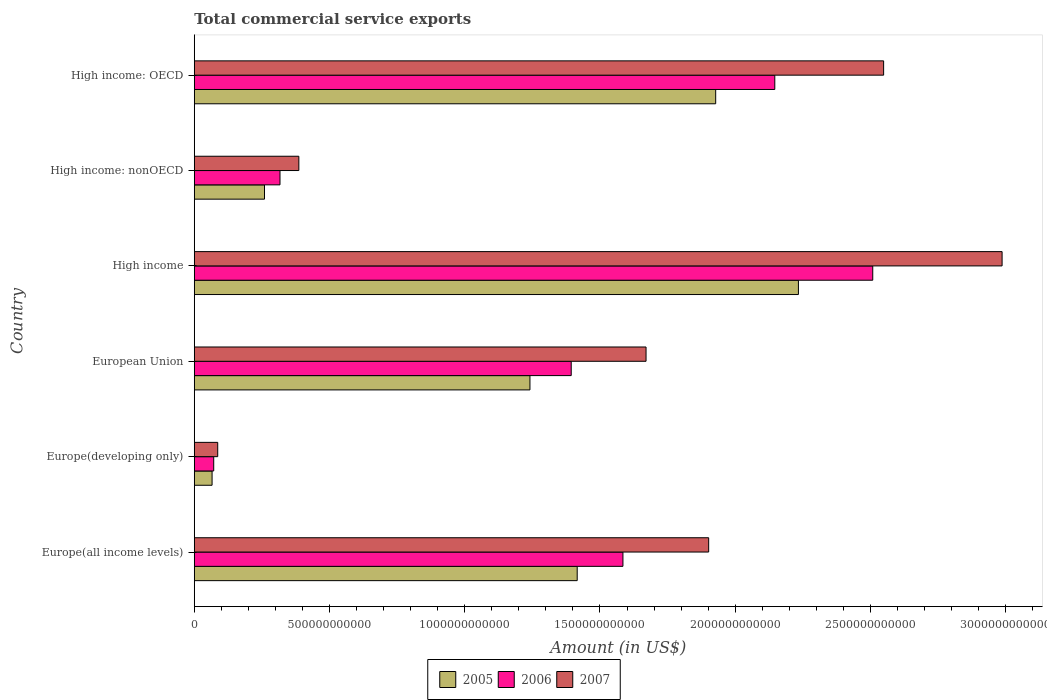How many groups of bars are there?
Provide a succinct answer. 6. Are the number of bars per tick equal to the number of legend labels?
Provide a short and direct response. Yes. Are the number of bars on each tick of the Y-axis equal?
Ensure brevity in your answer.  Yes. How many bars are there on the 3rd tick from the top?
Provide a succinct answer. 3. How many bars are there on the 6th tick from the bottom?
Provide a succinct answer. 3. What is the label of the 4th group of bars from the top?
Keep it short and to the point. European Union. What is the total commercial service exports in 2006 in High income: nonOECD?
Provide a short and direct response. 3.17e+11. Across all countries, what is the maximum total commercial service exports in 2005?
Ensure brevity in your answer.  2.23e+12. Across all countries, what is the minimum total commercial service exports in 2006?
Offer a terse response. 7.19e+1. In which country was the total commercial service exports in 2006 maximum?
Ensure brevity in your answer.  High income. In which country was the total commercial service exports in 2005 minimum?
Provide a short and direct response. Europe(developing only). What is the total total commercial service exports in 2006 in the graph?
Your answer should be compact. 8.02e+12. What is the difference between the total commercial service exports in 2005 in Europe(developing only) and that in High income: nonOECD?
Your answer should be compact. -1.94e+11. What is the difference between the total commercial service exports in 2005 in Europe(developing only) and the total commercial service exports in 2007 in Europe(all income levels)?
Offer a terse response. -1.84e+12. What is the average total commercial service exports in 2006 per country?
Keep it short and to the point. 1.34e+12. What is the difference between the total commercial service exports in 2006 and total commercial service exports in 2007 in High income?
Your answer should be very brief. -4.78e+11. What is the ratio of the total commercial service exports in 2005 in Europe(developing only) to that in High income: OECD?
Give a very brief answer. 0.03. Is the difference between the total commercial service exports in 2006 in Europe(all income levels) and High income: nonOECD greater than the difference between the total commercial service exports in 2007 in Europe(all income levels) and High income: nonOECD?
Provide a succinct answer. No. What is the difference between the highest and the second highest total commercial service exports in 2007?
Provide a short and direct response. 4.38e+11. What is the difference between the highest and the lowest total commercial service exports in 2006?
Your answer should be compact. 2.44e+12. Is the sum of the total commercial service exports in 2005 in Europe(developing only) and High income: nonOECD greater than the maximum total commercial service exports in 2007 across all countries?
Provide a succinct answer. No. What does the 2nd bar from the top in High income: OECD represents?
Provide a short and direct response. 2006. How many bars are there?
Give a very brief answer. 18. How many countries are there in the graph?
Keep it short and to the point. 6. What is the difference between two consecutive major ticks on the X-axis?
Provide a short and direct response. 5.00e+11. Are the values on the major ticks of X-axis written in scientific E-notation?
Make the answer very short. No. Does the graph contain any zero values?
Provide a succinct answer. No. What is the title of the graph?
Make the answer very short. Total commercial service exports. What is the label or title of the Y-axis?
Your answer should be very brief. Country. What is the Amount (in US$) of 2005 in Europe(all income levels)?
Offer a terse response. 1.42e+12. What is the Amount (in US$) in 2006 in Europe(all income levels)?
Give a very brief answer. 1.58e+12. What is the Amount (in US$) of 2007 in Europe(all income levels)?
Keep it short and to the point. 1.90e+12. What is the Amount (in US$) in 2005 in Europe(developing only)?
Keep it short and to the point. 6.59e+1. What is the Amount (in US$) in 2006 in Europe(developing only)?
Provide a succinct answer. 7.19e+1. What is the Amount (in US$) in 2007 in Europe(developing only)?
Offer a terse response. 8.67e+1. What is the Amount (in US$) of 2005 in European Union?
Ensure brevity in your answer.  1.24e+12. What is the Amount (in US$) in 2006 in European Union?
Offer a very short reply. 1.39e+12. What is the Amount (in US$) of 2007 in European Union?
Give a very brief answer. 1.67e+12. What is the Amount (in US$) of 2005 in High income?
Your response must be concise. 2.23e+12. What is the Amount (in US$) of 2006 in High income?
Provide a short and direct response. 2.51e+12. What is the Amount (in US$) of 2007 in High income?
Your answer should be compact. 2.99e+12. What is the Amount (in US$) of 2005 in High income: nonOECD?
Provide a short and direct response. 2.60e+11. What is the Amount (in US$) in 2006 in High income: nonOECD?
Keep it short and to the point. 3.17e+11. What is the Amount (in US$) of 2007 in High income: nonOECD?
Your answer should be compact. 3.87e+11. What is the Amount (in US$) in 2005 in High income: OECD?
Provide a short and direct response. 1.93e+12. What is the Amount (in US$) in 2006 in High income: OECD?
Offer a terse response. 2.15e+12. What is the Amount (in US$) in 2007 in High income: OECD?
Your answer should be compact. 2.55e+12. Across all countries, what is the maximum Amount (in US$) in 2005?
Make the answer very short. 2.23e+12. Across all countries, what is the maximum Amount (in US$) in 2006?
Offer a very short reply. 2.51e+12. Across all countries, what is the maximum Amount (in US$) in 2007?
Your response must be concise. 2.99e+12. Across all countries, what is the minimum Amount (in US$) in 2005?
Make the answer very short. 6.59e+1. Across all countries, what is the minimum Amount (in US$) in 2006?
Make the answer very short. 7.19e+1. Across all countries, what is the minimum Amount (in US$) in 2007?
Give a very brief answer. 8.67e+1. What is the total Amount (in US$) of 2005 in the graph?
Offer a very short reply. 7.14e+12. What is the total Amount (in US$) of 2006 in the graph?
Give a very brief answer. 8.02e+12. What is the total Amount (in US$) in 2007 in the graph?
Ensure brevity in your answer.  9.58e+12. What is the difference between the Amount (in US$) of 2005 in Europe(all income levels) and that in Europe(developing only)?
Make the answer very short. 1.35e+12. What is the difference between the Amount (in US$) in 2006 in Europe(all income levels) and that in Europe(developing only)?
Your response must be concise. 1.51e+12. What is the difference between the Amount (in US$) in 2007 in Europe(all income levels) and that in Europe(developing only)?
Provide a short and direct response. 1.82e+12. What is the difference between the Amount (in US$) in 2005 in Europe(all income levels) and that in European Union?
Offer a very short reply. 1.75e+11. What is the difference between the Amount (in US$) of 2006 in Europe(all income levels) and that in European Union?
Your answer should be very brief. 1.91e+11. What is the difference between the Amount (in US$) of 2007 in Europe(all income levels) and that in European Union?
Your answer should be very brief. 2.32e+11. What is the difference between the Amount (in US$) in 2005 in Europe(all income levels) and that in High income?
Provide a succinct answer. -8.18e+11. What is the difference between the Amount (in US$) of 2006 in Europe(all income levels) and that in High income?
Provide a succinct answer. -9.24e+11. What is the difference between the Amount (in US$) of 2007 in Europe(all income levels) and that in High income?
Provide a succinct answer. -1.08e+12. What is the difference between the Amount (in US$) of 2005 in Europe(all income levels) and that in High income: nonOECD?
Offer a terse response. 1.16e+12. What is the difference between the Amount (in US$) in 2006 in Europe(all income levels) and that in High income: nonOECD?
Keep it short and to the point. 1.27e+12. What is the difference between the Amount (in US$) of 2007 in Europe(all income levels) and that in High income: nonOECD?
Make the answer very short. 1.52e+12. What is the difference between the Amount (in US$) of 2005 in Europe(all income levels) and that in High income: OECD?
Make the answer very short. -5.12e+11. What is the difference between the Amount (in US$) of 2006 in Europe(all income levels) and that in High income: OECD?
Your answer should be very brief. -5.61e+11. What is the difference between the Amount (in US$) of 2007 in Europe(all income levels) and that in High income: OECD?
Ensure brevity in your answer.  -6.47e+11. What is the difference between the Amount (in US$) in 2005 in Europe(developing only) and that in European Union?
Offer a very short reply. -1.18e+12. What is the difference between the Amount (in US$) of 2006 in Europe(developing only) and that in European Union?
Make the answer very short. -1.32e+12. What is the difference between the Amount (in US$) of 2007 in Europe(developing only) and that in European Union?
Your answer should be very brief. -1.58e+12. What is the difference between the Amount (in US$) of 2005 in Europe(developing only) and that in High income?
Your answer should be very brief. -2.17e+12. What is the difference between the Amount (in US$) in 2006 in Europe(developing only) and that in High income?
Provide a short and direct response. -2.44e+12. What is the difference between the Amount (in US$) of 2007 in Europe(developing only) and that in High income?
Make the answer very short. -2.90e+12. What is the difference between the Amount (in US$) in 2005 in Europe(developing only) and that in High income: nonOECD?
Ensure brevity in your answer.  -1.94e+11. What is the difference between the Amount (in US$) of 2006 in Europe(developing only) and that in High income: nonOECD?
Make the answer very short. -2.45e+11. What is the difference between the Amount (in US$) of 2007 in Europe(developing only) and that in High income: nonOECD?
Your response must be concise. -3.00e+11. What is the difference between the Amount (in US$) of 2005 in Europe(developing only) and that in High income: OECD?
Make the answer very short. -1.86e+12. What is the difference between the Amount (in US$) in 2006 in Europe(developing only) and that in High income: OECD?
Offer a terse response. -2.07e+12. What is the difference between the Amount (in US$) of 2007 in Europe(developing only) and that in High income: OECD?
Ensure brevity in your answer.  -2.46e+12. What is the difference between the Amount (in US$) of 2005 in European Union and that in High income?
Keep it short and to the point. -9.93e+11. What is the difference between the Amount (in US$) of 2006 in European Union and that in High income?
Provide a succinct answer. -1.11e+12. What is the difference between the Amount (in US$) in 2007 in European Union and that in High income?
Provide a succinct answer. -1.32e+12. What is the difference between the Amount (in US$) of 2005 in European Union and that in High income: nonOECD?
Your answer should be compact. 9.81e+11. What is the difference between the Amount (in US$) in 2006 in European Union and that in High income: nonOECD?
Your answer should be compact. 1.08e+12. What is the difference between the Amount (in US$) of 2007 in European Union and that in High income: nonOECD?
Keep it short and to the point. 1.28e+12. What is the difference between the Amount (in US$) of 2005 in European Union and that in High income: OECD?
Give a very brief answer. -6.87e+11. What is the difference between the Amount (in US$) of 2006 in European Union and that in High income: OECD?
Your answer should be very brief. -7.53e+11. What is the difference between the Amount (in US$) in 2007 in European Union and that in High income: OECD?
Keep it short and to the point. -8.78e+11. What is the difference between the Amount (in US$) of 2005 in High income and that in High income: nonOECD?
Provide a short and direct response. 1.97e+12. What is the difference between the Amount (in US$) in 2006 in High income and that in High income: nonOECD?
Your answer should be very brief. 2.19e+12. What is the difference between the Amount (in US$) of 2007 in High income and that in High income: nonOECD?
Your answer should be very brief. 2.60e+12. What is the difference between the Amount (in US$) in 2005 in High income and that in High income: OECD?
Make the answer very short. 3.06e+11. What is the difference between the Amount (in US$) in 2006 in High income and that in High income: OECD?
Your answer should be compact. 3.62e+11. What is the difference between the Amount (in US$) in 2007 in High income and that in High income: OECD?
Offer a very short reply. 4.38e+11. What is the difference between the Amount (in US$) in 2005 in High income: nonOECD and that in High income: OECD?
Your answer should be compact. -1.67e+12. What is the difference between the Amount (in US$) in 2006 in High income: nonOECD and that in High income: OECD?
Give a very brief answer. -1.83e+12. What is the difference between the Amount (in US$) in 2007 in High income: nonOECD and that in High income: OECD?
Provide a succinct answer. -2.16e+12. What is the difference between the Amount (in US$) in 2005 in Europe(all income levels) and the Amount (in US$) in 2006 in Europe(developing only)?
Your response must be concise. 1.34e+12. What is the difference between the Amount (in US$) in 2005 in Europe(all income levels) and the Amount (in US$) in 2007 in Europe(developing only)?
Your answer should be very brief. 1.33e+12. What is the difference between the Amount (in US$) of 2006 in Europe(all income levels) and the Amount (in US$) of 2007 in Europe(developing only)?
Offer a very short reply. 1.50e+12. What is the difference between the Amount (in US$) of 2005 in Europe(all income levels) and the Amount (in US$) of 2006 in European Union?
Keep it short and to the point. 2.21e+1. What is the difference between the Amount (in US$) of 2005 in Europe(all income levels) and the Amount (in US$) of 2007 in European Union?
Offer a very short reply. -2.55e+11. What is the difference between the Amount (in US$) of 2006 in Europe(all income levels) and the Amount (in US$) of 2007 in European Union?
Your answer should be compact. -8.55e+1. What is the difference between the Amount (in US$) of 2005 in Europe(all income levels) and the Amount (in US$) of 2006 in High income?
Your response must be concise. -1.09e+12. What is the difference between the Amount (in US$) of 2005 in Europe(all income levels) and the Amount (in US$) of 2007 in High income?
Provide a short and direct response. -1.57e+12. What is the difference between the Amount (in US$) of 2006 in Europe(all income levels) and the Amount (in US$) of 2007 in High income?
Your answer should be very brief. -1.40e+12. What is the difference between the Amount (in US$) of 2005 in Europe(all income levels) and the Amount (in US$) of 2006 in High income: nonOECD?
Offer a very short reply. 1.10e+12. What is the difference between the Amount (in US$) of 2005 in Europe(all income levels) and the Amount (in US$) of 2007 in High income: nonOECD?
Make the answer very short. 1.03e+12. What is the difference between the Amount (in US$) in 2006 in Europe(all income levels) and the Amount (in US$) in 2007 in High income: nonOECD?
Your response must be concise. 1.20e+12. What is the difference between the Amount (in US$) of 2005 in Europe(all income levels) and the Amount (in US$) of 2006 in High income: OECD?
Give a very brief answer. -7.31e+11. What is the difference between the Amount (in US$) of 2005 in Europe(all income levels) and the Amount (in US$) of 2007 in High income: OECD?
Offer a terse response. -1.13e+12. What is the difference between the Amount (in US$) of 2006 in Europe(all income levels) and the Amount (in US$) of 2007 in High income: OECD?
Keep it short and to the point. -9.64e+11. What is the difference between the Amount (in US$) in 2005 in Europe(developing only) and the Amount (in US$) in 2006 in European Union?
Your response must be concise. -1.33e+12. What is the difference between the Amount (in US$) of 2005 in Europe(developing only) and the Amount (in US$) of 2007 in European Union?
Ensure brevity in your answer.  -1.60e+12. What is the difference between the Amount (in US$) of 2006 in Europe(developing only) and the Amount (in US$) of 2007 in European Union?
Make the answer very short. -1.60e+12. What is the difference between the Amount (in US$) of 2005 in Europe(developing only) and the Amount (in US$) of 2006 in High income?
Your answer should be compact. -2.44e+12. What is the difference between the Amount (in US$) of 2005 in Europe(developing only) and the Amount (in US$) of 2007 in High income?
Provide a short and direct response. -2.92e+12. What is the difference between the Amount (in US$) in 2006 in Europe(developing only) and the Amount (in US$) in 2007 in High income?
Your answer should be very brief. -2.91e+12. What is the difference between the Amount (in US$) of 2005 in Europe(developing only) and the Amount (in US$) of 2006 in High income: nonOECD?
Offer a terse response. -2.51e+11. What is the difference between the Amount (in US$) of 2005 in Europe(developing only) and the Amount (in US$) of 2007 in High income: nonOECD?
Your answer should be compact. -3.21e+11. What is the difference between the Amount (in US$) in 2006 in Europe(developing only) and the Amount (in US$) in 2007 in High income: nonOECD?
Your answer should be very brief. -3.15e+11. What is the difference between the Amount (in US$) in 2005 in Europe(developing only) and the Amount (in US$) in 2006 in High income: OECD?
Make the answer very short. -2.08e+12. What is the difference between the Amount (in US$) of 2005 in Europe(developing only) and the Amount (in US$) of 2007 in High income: OECD?
Give a very brief answer. -2.48e+12. What is the difference between the Amount (in US$) in 2006 in Europe(developing only) and the Amount (in US$) in 2007 in High income: OECD?
Offer a very short reply. -2.48e+12. What is the difference between the Amount (in US$) of 2005 in European Union and the Amount (in US$) of 2006 in High income?
Offer a terse response. -1.27e+12. What is the difference between the Amount (in US$) of 2005 in European Union and the Amount (in US$) of 2007 in High income?
Provide a short and direct response. -1.75e+12. What is the difference between the Amount (in US$) of 2006 in European Union and the Amount (in US$) of 2007 in High income?
Keep it short and to the point. -1.59e+12. What is the difference between the Amount (in US$) of 2005 in European Union and the Amount (in US$) of 2006 in High income: nonOECD?
Keep it short and to the point. 9.24e+11. What is the difference between the Amount (in US$) in 2005 in European Union and the Amount (in US$) in 2007 in High income: nonOECD?
Give a very brief answer. 8.55e+11. What is the difference between the Amount (in US$) in 2006 in European Union and the Amount (in US$) in 2007 in High income: nonOECD?
Keep it short and to the point. 1.01e+12. What is the difference between the Amount (in US$) of 2005 in European Union and the Amount (in US$) of 2006 in High income: OECD?
Make the answer very short. -9.05e+11. What is the difference between the Amount (in US$) of 2005 in European Union and the Amount (in US$) of 2007 in High income: OECD?
Your answer should be compact. -1.31e+12. What is the difference between the Amount (in US$) of 2006 in European Union and the Amount (in US$) of 2007 in High income: OECD?
Your answer should be very brief. -1.16e+12. What is the difference between the Amount (in US$) in 2005 in High income and the Amount (in US$) in 2006 in High income: nonOECD?
Offer a very short reply. 1.92e+12. What is the difference between the Amount (in US$) of 2005 in High income and the Amount (in US$) of 2007 in High income: nonOECD?
Offer a terse response. 1.85e+12. What is the difference between the Amount (in US$) of 2006 in High income and the Amount (in US$) of 2007 in High income: nonOECD?
Keep it short and to the point. 2.12e+12. What is the difference between the Amount (in US$) in 2005 in High income and the Amount (in US$) in 2006 in High income: OECD?
Give a very brief answer. 8.74e+1. What is the difference between the Amount (in US$) of 2005 in High income and the Amount (in US$) of 2007 in High income: OECD?
Give a very brief answer. -3.15e+11. What is the difference between the Amount (in US$) of 2006 in High income and the Amount (in US$) of 2007 in High income: OECD?
Give a very brief answer. -4.02e+1. What is the difference between the Amount (in US$) of 2005 in High income: nonOECD and the Amount (in US$) of 2006 in High income: OECD?
Provide a short and direct response. -1.89e+12. What is the difference between the Amount (in US$) in 2005 in High income: nonOECD and the Amount (in US$) in 2007 in High income: OECD?
Give a very brief answer. -2.29e+12. What is the difference between the Amount (in US$) in 2006 in High income: nonOECD and the Amount (in US$) in 2007 in High income: OECD?
Keep it short and to the point. -2.23e+12. What is the average Amount (in US$) in 2005 per country?
Provide a succinct answer. 1.19e+12. What is the average Amount (in US$) in 2006 per country?
Ensure brevity in your answer.  1.34e+12. What is the average Amount (in US$) in 2007 per country?
Your answer should be very brief. 1.60e+12. What is the difference between the Amount (in US$) of 2005 and Amount (in US$) of 2006 in Europe(all income levels)?
Ensure brevity in your answer.  -1.69e+11. What is the difference between the Amount (in US$) in 2005 and Amount (in US$) in 2007 in Europe(all income levels)?
Your answer should be very brief. -4.86e+11. What is the difference between the Amount (in US$) in 2006 and Amount (in US$) in 2007 in Europe(all income levels)?
Provide a short and direct response. -3.17e+11. What is the difference between the Amount (in US$) of 2005 and Amount (in US$) of 2006 in Europe(developing only)?
Ensure brevity in your answer.  -6.08e+09. What is the difference between the Amount (in US$) of 2005 and Amount (in US$) of 2007 in Europe(developing only)?
Provide a succinct answer. -2.09e+1. What is the difference between the Amount (in US$) in 2006 and Amount (in US$) in 2007 in Europe(developing only)?
Provide a succinct answer. -1.48e+1. What is the difference between the Amount (in US$) in 2005 and Amount (in US$) in 2006 in European Union?
Offer a very short reply. -1.53e+11. What is the difference between the Amount (in US$) of 2005 and Amount (in US$) of 2007 in European Union?
Your answer should be compact. -4.29e+11. What is the difference between the Amount (in US$) in 2006 and Amount (in US$) in 2007 in European Union?
Make the answer very short. -2.77e+11. What is the difference between the Amount (in US$) of 2005 and Amount (in US$) of 2006 in High income?
Keep it short and to the point. -2.75e+11. What is the difference between the Amount (in US$) in 2005 and Amount (in US$) in 2007 in High income?
Keep it short and to the point. -7.53e+11. What is the difference between the Amount (in US$) of 2006 and Amount (in US$) of 2007 in High income?
Your response must be concise. -4.78e+11. What is the difference between the Amount (in US$) of 2005 and Amount (in US$) of 2006 in High income: nonOECD?
Offer a terse response. -5.73e+1. What is the difference between the Amount (in US$) of 2005 and Amount (in US$) of 2007 in High income: nonOECD?
Ensure brevity in your answer.  -1.27e+11. What is the difference between the Amount (in US$) of 2006 and Amount (in US$) of 2007 in High income: nonOECD?
Offer a very short reply. -6.97e+1. What is the difference between the Amount (in US$) in 2005 and Amount (in US$) in 2006 in High income: OECD?
Your response must be concise. -2.19e+11. What is the difference between the Amount (in US$) of 2005 and Amount (in US$) of 2007 in High income: OECD?
Make the answer very short. -6.21e+11. What is the difference between the Amount (in US$) of 2006 and Amount (in US$) of 2007 in High income: OECD?
Offer a very short reply. -4.02e+11. What is the ratio of the Amount (in US$) in 2005 in Europe(all income levels) to that in Europe(developing only)?
Offer a very short reply. 21.5. What is the ratio of the Amount (in US$) in 2006 in Europe(all income levels) to that in Europe(developing only)?
Provide a short and direct response. 22.03. What is the ratio of the Amount (in US$) in 2007 in Europe(all income levels) to that in Europe(developing only)?
Make the answer very short. 21.93. What is the ratio of the Amount (in US$) of 2005 in Europe(all income levels) to that in European Union?
Offer a very short reply. 1.14. What is the ratio of the Amount (in US$) in 2006 in Europe(all income levels) to that in European Union?
Your answer should be compact. 1.14. What is the ratio of the Amount (in US$) of 2007 in Europe(all income levels) to that in European Union?
Ensure brevity in your answer.  1.14. What is the ratio of the Amount (in US$) of 2005 in Europe(all income levels) to that in High income?
Offer a terse response. 0.63. What is the ratio of the Amount (in US$) of 2006 in Europe(all income levels) to that in High income?
Make the answer very short. 0.63. What is the ratio of the Amount (in US$) of 2007 in Europe(all income levels) to that in High income?
Keep it short and to the point. 0.64. What is the ratio of the Amount (in US$) of 2005 in Europe(all income levels) to that in High income: nonOECD?
Offer a very short reply. 5.45. What is the ratio of the Amount (in US$) in 2006 in Europe(all income levels) to that in High income: nonOECD?
Keep it short and to the point. 5. What is the ratio of the Amount (in US$) in 2007 in Europe(all income levels) to that in High income: nonOECD?
Make the answer very short. 4.92. What is the ratio of the Amount (in US$) in 2005 in Europe(all income levels) to that in High income: OECD?
Your answer should be very brief. 0.73. What is the ratio of the Amount (in US$) in 2006 in Europe(all income levels) to that in High income: OECD?
Offer a terse response. 0.74. What is the ratio of the Amount (in US$) in 2007 in Europe(all income levels) to that in High income: OECD?
Provide a succinct answer. 0.75. What is the ratio of the Amount (in US$) of 2005 in Europe(developing only) to that in European Union?
Keep it short and to the point. 0.05. What is the ratio of the Amount (in US$) of 2006 in Europe(developing only) to that in European Union?
Give a very brief answer. 0.05. What is the ratio of the Amount (in US$) of 2007 in Europe(developing only) to that in European Union?
Your answer should be very brief. 0.05. What is the ratio of the Amount (in US$) in 2005 in Europe(developing only) to that in High income?
Your response must be concise. 0.03. What is the ratio of the Amount (in US$) in 2006 in Europe(developing only) to that in High income?
Give a very brief answer. 0.03. What is the ratio of the Amount (in US$) in 2007 in Europe(developing only) to that in High income?
Offer a very short reply. 0.03. What is the ratio of the Amount (in US$) in 2005 in Europe(developing only) to that in High income: nonOECD?
Your response must be concise. 0.25. What is the ratio of the Amount (in US$) of 2006 in Europe(developing only) to that in High income: nonOECD?
Offer a very short reply. 0.23. What is the ratio of the Amount (in US$) of 2007 in Europe(developing only) to that in High income: nonOECD?
Provide a succinct answer. 0.22. What is the ratio of the Amount (in US$) in 2005 in Europe(developing only) to that in High income: OECD?
Your answer should be compact. 0.03. What is the ratio of the Amount (in US$) of 2006 in Europe(developing only) to that in High income: OECD?
Your response must be concise. 0.03. What is the ratio of the Amount (in US$) of 2007 in Europe(developing only) to that in High income: OECD?
Give a very brief answer. 0.03. What is the ratio of the Amount (in US$) of 2005 in European Union to that in High income?
Ensure brevity in your answer.  0.56. What is the ratio of the Amount (in US$) in 2006 in European Union to that in High income?
Ensure brevity in your answer.  0.56. What is the ratio of the Amount (in US$) of 2007 in European Union to that in High income?
Offer a terse response. 0.56. What is the ratio of the Amount (in US$) of 2005 in European Union to that in High income: nonOECD?
Provide a short and direct response. 4.78. What is the ratio of the Amount (in US$) of 2006 in European Union to that in High income: nonOECD?
Ensure brevity in your answer.  4.4. What is the ratio of the Amount (in US$) of 2007 in European Union to that in High income: nonOECD?
Ensure brevity in your answer.  4.32. What is the ratio of the Amount (in US$) in 2005 in European Union to that in High income: OECD?
Give a very brief answer. 0.64. What is the ratio of the Amount (in US$) in 2006 in European Union to that in High income: OECD?
Provide a succinct answer. 0.65. What is the ratio of the Amount (in US$) in 2007 in European Union to that in High income: OECD?
Ensure brevity in your answer.  0.66. What is the ratio of the Amount (in US$) in 2005 in High income to that in High income: nonOECD?
Make the answer very short. 8.6. What is the ratio of the Amount (in US$) in 2006 in High income to that in High income: nonOECD?
Provide a succinct answer. 7.91. What is the ratio of the Amount (in US$) in 2007 in High income to that in High income: nonOECD?
Offer a terse response. 7.72. What is the ratio of the Amount (in US$) in 2005 in High income to that in High income: OECD?
Offer a terse response. 1.16. What is the ratio of the Amount (in US$) of 2006 in High income to that in High income: OECD?
Keep it short and to the point. 1.17. What is the ratio of the Amount (in US$) of 2007 in High income to that in High income: OECD?
Provide a succinct answer. 1.17. What is the ratio of the Amount (in US$) of 2005 in High income: nonOECD to that in High income: OECD?
Offer a very short reply. 0.13. What is the ratio of the Amount (in US$) of 2006 in High income: nonOECD to that in High income: OECD?
Your answer should be very brief. 0.15. What is the ratio of the Amount (in US$) in 2007 in High income: nonOECD to that in High income: OECD?
Your answer should be compact. 0.15. What is the difference between the highest and the second highest Amount (in US$) in 2005?
Make the answer very short. 3.06e+11. What is the difference between the highest and the second highest Amount (in US$) of 2006?
Your answer should be compact. 3.62e+11. What is the difference between the highest and the second highest Amount (in US$) of 2007?
Offer a terse response. 4.38e+11. What is the difference between the highest and the lowest Amount (in US$) of 2005?
Make the answer very short. 2.17e+12. What is the difference between the highest and the lowest Amount (in US$) of 2006?
Provide a short and direct response. 2.44e+12. What is the difference between the highest and the lowest Amount (in US$) in 2007?
Your answer should be very brief. 2.90e+12. 